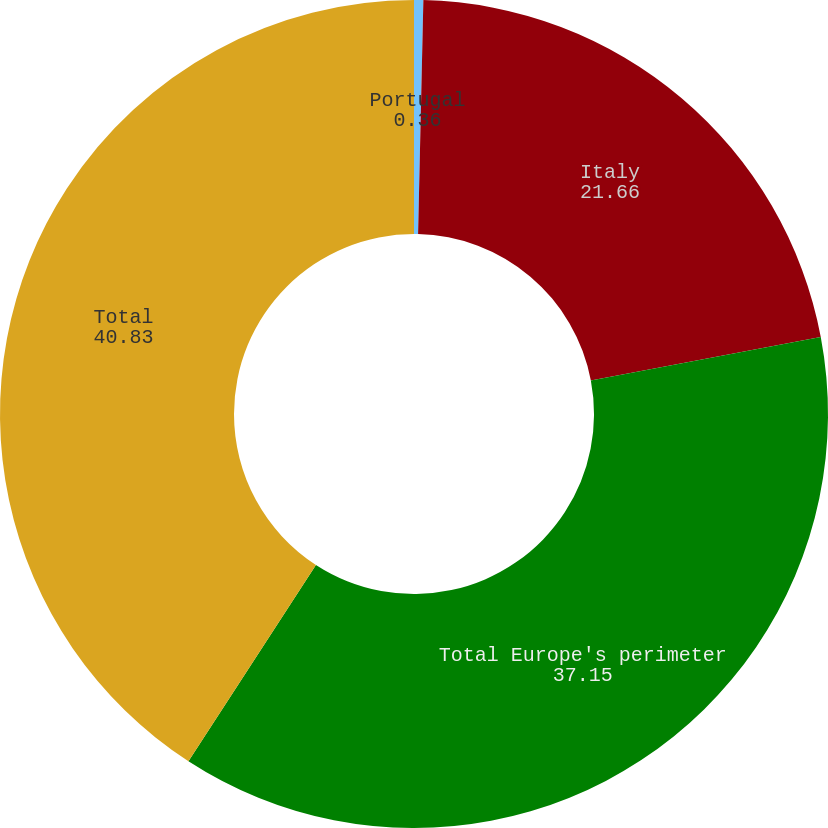Convert chart to OTSL. <chart><loc_0><loc_0><loc_500><loc_500><pie_chart><fcel>Portugal<fcel>Italy<fcel>Total Europe's perimeter<fcel>Total<nl><fcel>0.36%<fcel>21.66%<fcel>37.15%<fcel>40.83%<nl></chart> 